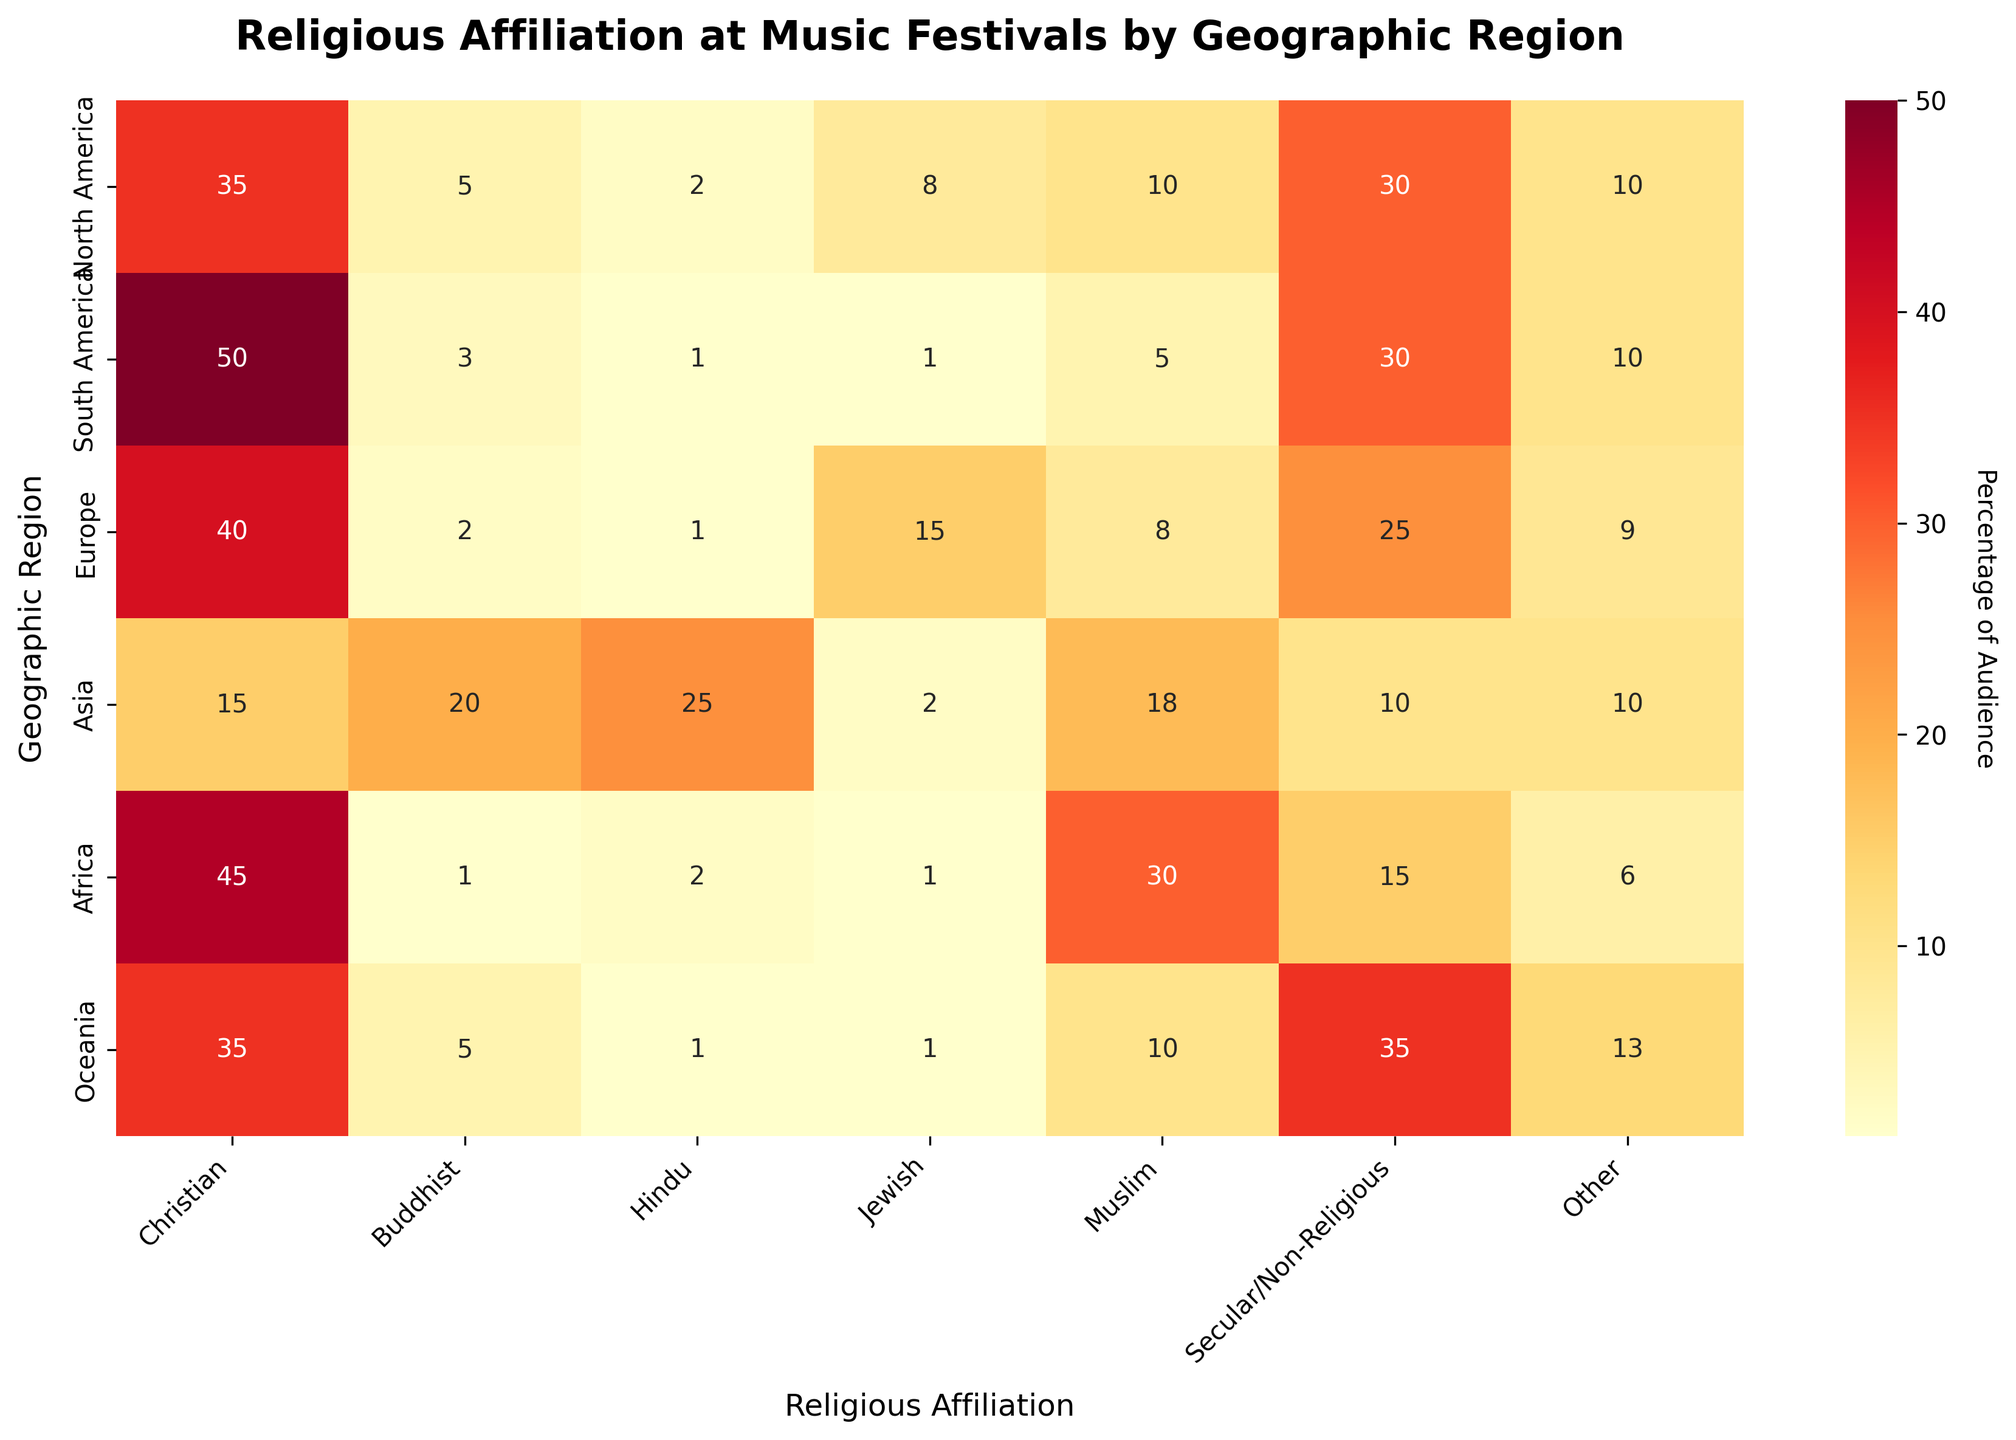What is the title of the heatmap? The title is at the top of the heatmap in bold font, indicating the main subject of the visualization.
Answer: Religious Affiliation at Music Festivals by Geographic Region Which region has the highest percentage of audience identifying as Hindus? Look at the column for Hindu affiliation and find the highest value.
Answer: Asia What percentage of the audience in Europe identifies as Jewish? Find the value in the Europe row and Jewish column.
Answer: 15 How does the percentage of Secular/Non-Religious audience in Oceania compare to North America? Compare the values in the Secular/Non-Religious column for Oceania and North America.
Answer: Higher in Oceania Which religious affiliation has the lowest representation in South America? Look at the South America row and identify the smallest value.
Answer: Hindu, Jewish, and Other (all 1) What is the total percentage of Christian audience across all regions? Sum the values in the Christian column. The values are: 35 (NA) + 50 (SA) + 40 (EU) + 15 (AS) + 45 (AF) + 35 (OC). The sum is 35 + 50 + 40 + 15 + 45 + 35 = 220
Answer: 220 How does the percentage of audience identifying as Muslims in Africa compare to Asia? Compare the values in the Muslim column for Africa (30) and Asia (18).
Answer: Higher in Africa Which region has the most diverse range of religious affiliations (assumed as the region with the most different affiliations represented)? Identify the region with the highest number of different values across different affiliations.
Answer: Asia How many regions have a higher percentage of Jewish audience than a Muslim audience? Count the number of regions where the value in the Jewish column is greater than that in the Muslim column: North America (no), South America (no), Europe (yes), Asia (no), Africa (no), Oceania (no).
Answer: 1 What is the average percentage of Audience identifying as 'Other' across all regions? Sum the values in the 'Other' column and then divide by the number of regions (6). The values are: 10 (NA), 10 (SA), 9 (EU), 10 (AS), 6 (AF), and 13 (OC). The sum is 10 + 10 + 9 + 10 + 6 + 13 = 58. The average is 58 / 6 ≈ 9.67
Answer: 9.67 